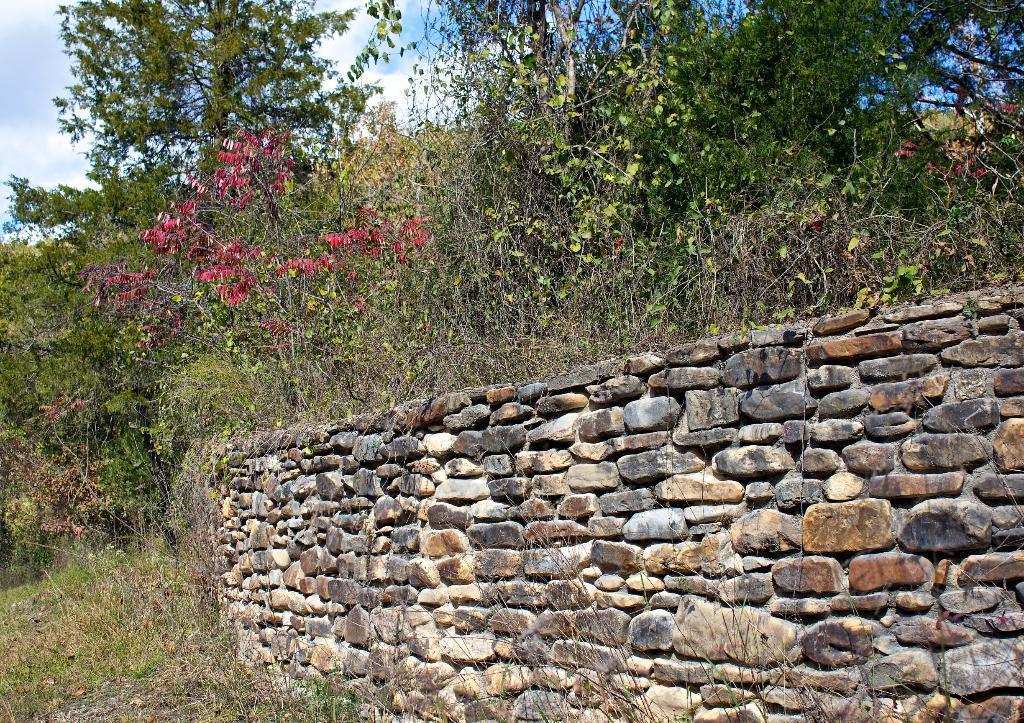Please provide a concise description of this image. In this image we can see a wall built with some stones. We can also see a group of plants with flowers, trees and the sky which looks cloudy. 